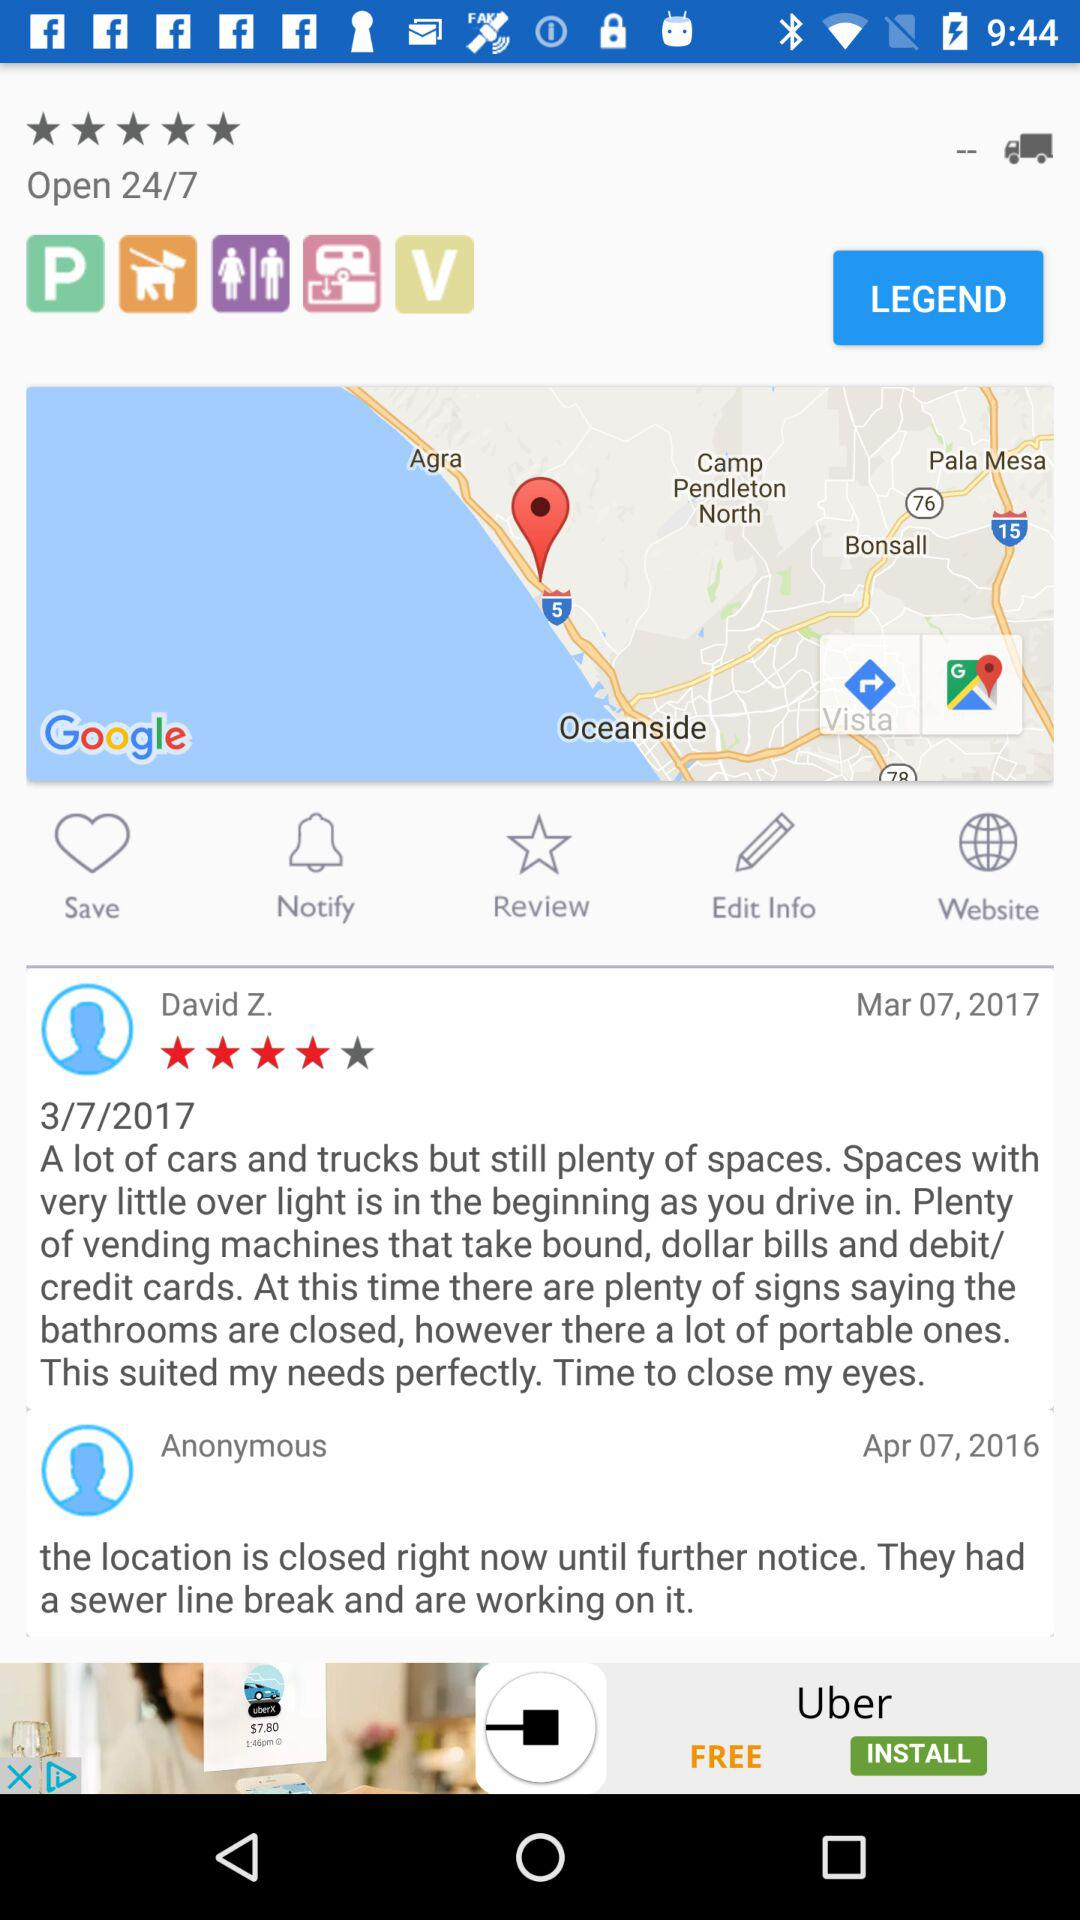How many reviews are there for this location?
Answer the question using a single word or phrase. 2 